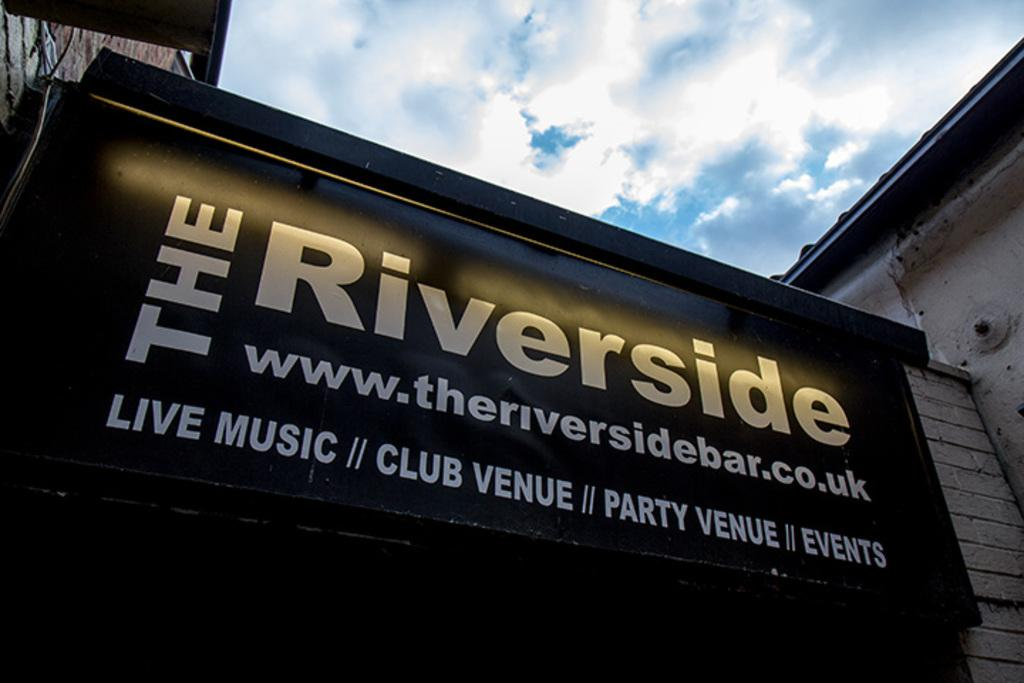What is the main structure in the image? There is a building with a name board in the image. What can be found on the building? Something is written on the name board. What type of wall is present in the image? There is a brick wall in the image. What is visible in the background of the image? The sky is visible in the background of the image. What can be observed in the sky? There are clouds in the sky. How many eggs are visible on the name board in the image? There are no eggs present on the name board in the image. What type of tooth can be seen in the image? There is no tooth visible in the image. 